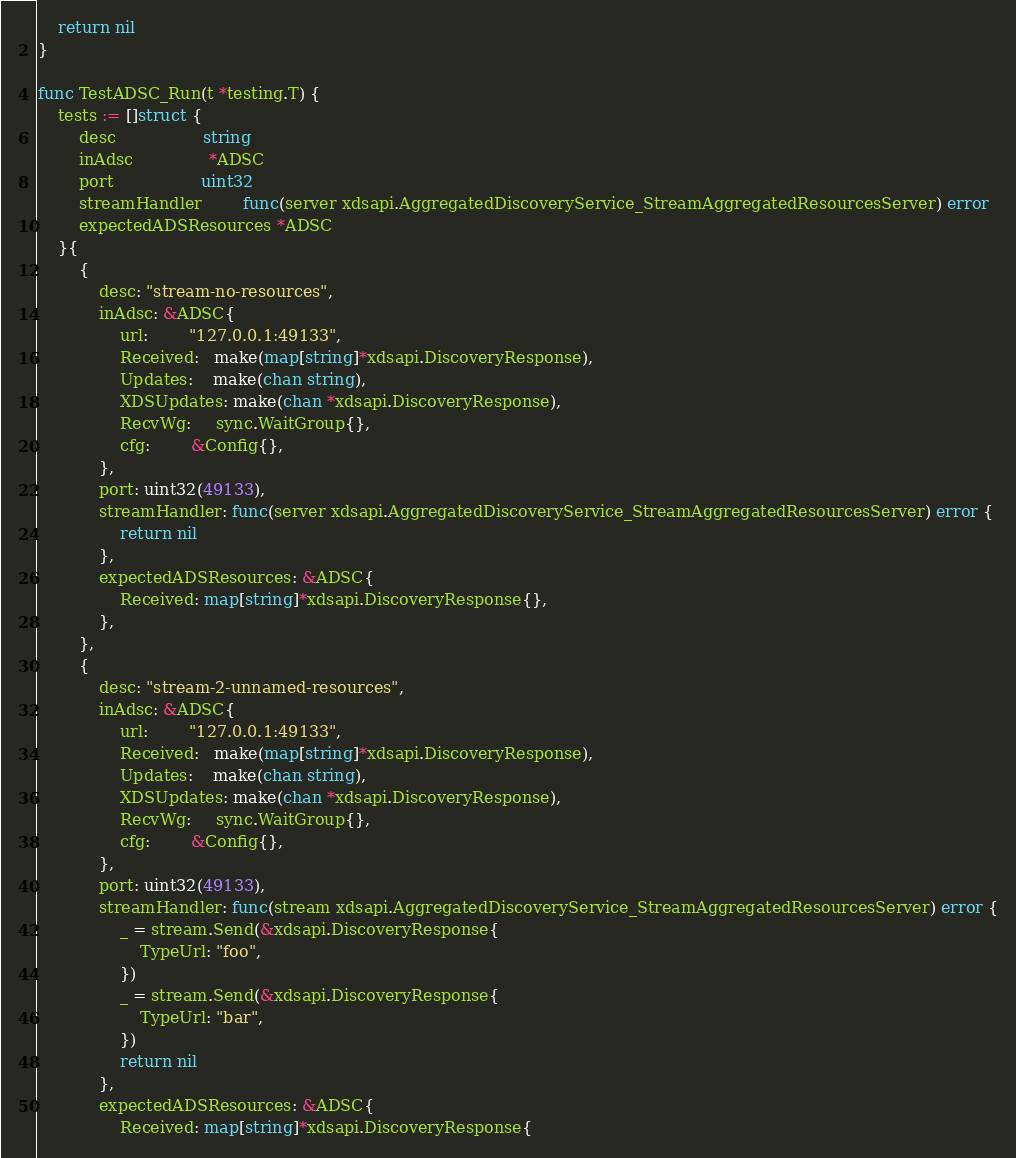<code> <loc_0><loc_0><loc_500><loc_500><_Go_>	return nil
}

func TestADSC_Run(t *testing.T) {
	tests := []struct {
		desc                 string
		inAdsc               *ADSC
		port                 uint32
		streamHandler        func(server xdsapi.AggregatedDiscoveryService_StreamAggregatedResourcesServer) error
		expectedADSResources *ADSC
	}{
		{
			desc: "stream-no-resources",
			inAdsc: &ADSC{
				url:        "127.0.0.1:49133",
				Received:   make(map[string]*xdsapi.DiscoveryResponse),
				Updates:    make(chan string),
				XDSUpdates: make(chan *xdsapi.DiscoveryResponse),
				RecvWg:     sync.WaitGroup{},
				cfg:        &Config{},
			},
			port: uint32(49133),
			streamHandler: func(server xdsapi.AggregatedDiscoveryService_StreamAggregatedResourcesServer) error {
				return nil
			},
			expectedADSResources: &ADSC{
				Received: map[string]*xdsapi.DiscoveryResponse{},
			},
		},
		{
			desc: "stream-2-unnamed-resources",
			inAdsc: &ADSC{
				url:        "127.0.0.1:49133",
				Received:   make(map[string]*xdsapi.DiscoveryResponse),
				Updates:    make(chan string),
				XDSUpdates: make(chan *xdsapi.DiscoveryResponse),
				RecvWg:     sync.WaitGroup{},
				cfg:        &Config{},
			},
			port: uint32(49133),
			streamHandler: func(stream xdsapi.AggregatedDiscoveryService_StreamAggregatedResourcesServer) error {
				_ = stream.Send(&xdsapi.DiscoveryResponse{
					TypeUrl: "foo",
				})
				_ = stream.Send(&xdsapi.DiscoveryResponse{
					TypeUrl: "bar",
				})
				return nil
			},
			expectedADSResources: &ADSC{
				Received: map[string]*xdsapi.DiscoveryResponse{</code> 